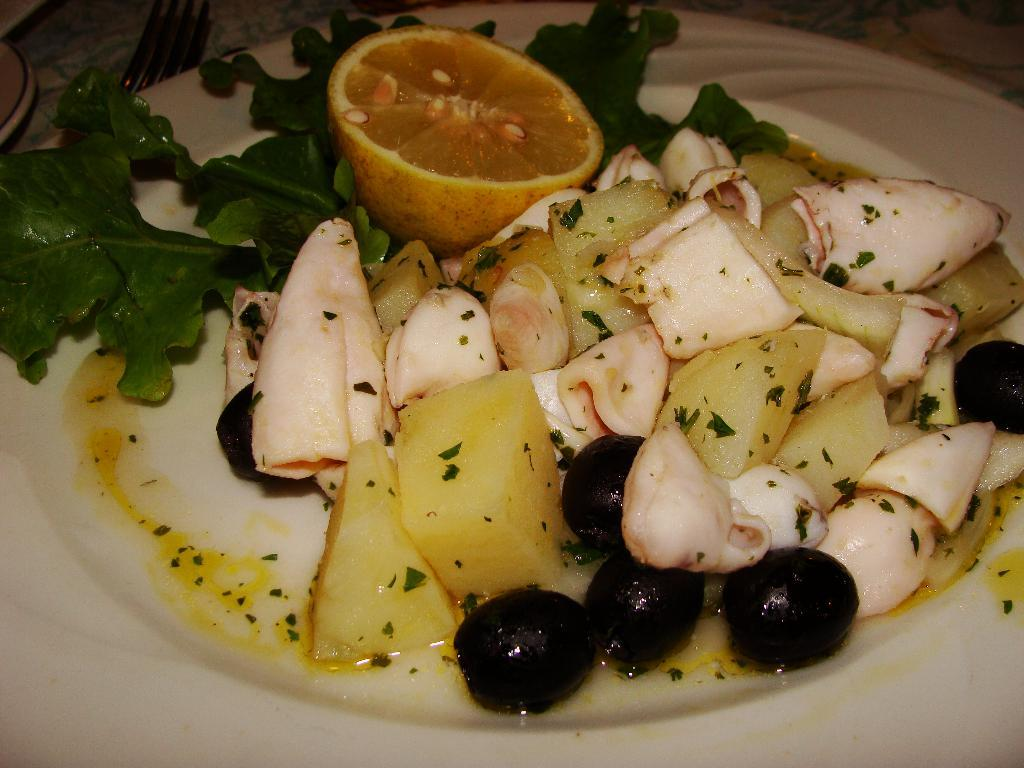What is on the white plate in the image? There is food on a white plate in the image. How many forks are visible in the image? There is one fork visible in the image. How many plates are on the table in the image? There are two plates on the table in the image. What type of throne is present in the image? There is no throne present in the image. How are the scissors being used in the image? There are no scissors present in the image. 